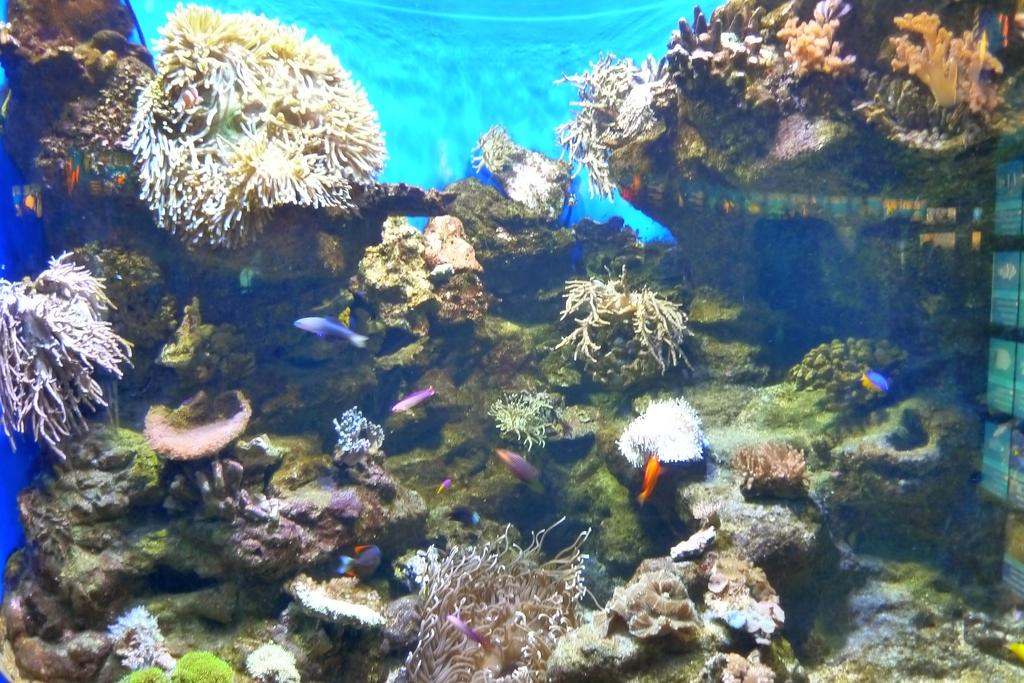What type of animals can be seen in the image? There are fishes in the water. What can be seen in the background of the image? There are plants and rocks in the water in the background of the image. What is the color of the background in the image? The background color is blue. How many basketballs can be seen in the image? There are no basketballs present in the image. What type of steel structure is visible in the image? There is no steel structure present in the image. 